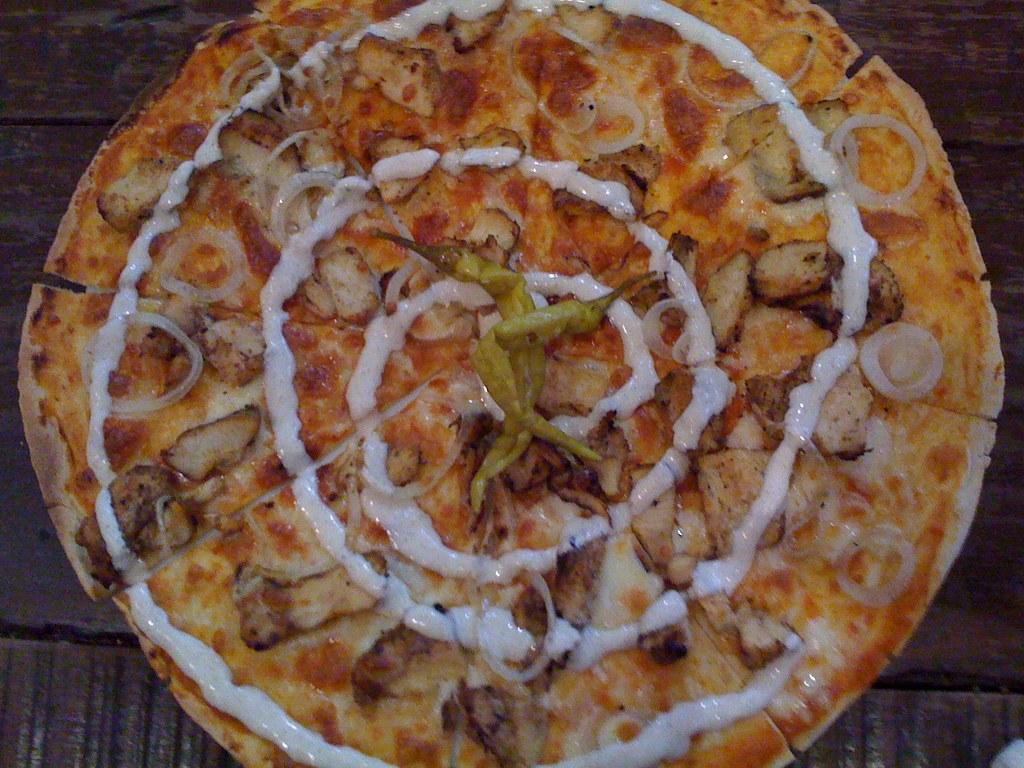What is the main subject of the image? There is a food item in the image. What specific ingredients can be seen on the food item? There are green chilies and cream on the food item. What historical event is depicted in the image? There is no historical event depicted in the image; it features a food item with green chilies and cream. What type of floor is visible in the image? There is no floor visible in the image; it focuses on the food item. 